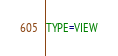Convert code to text. <code><loc_0><loc_0><loc_500><loc_500><_VisualBasic_>TYPE=VIEW</code> 